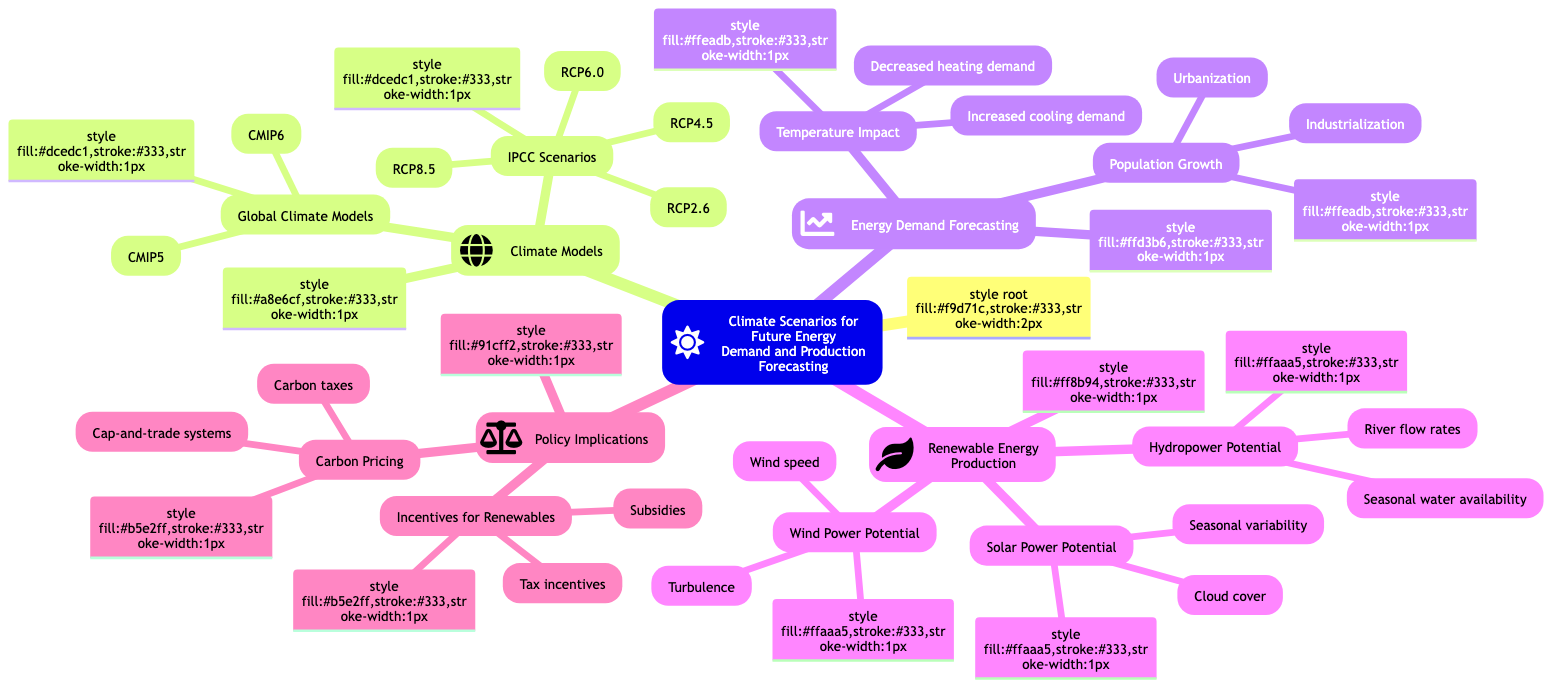What is the central theme of the diagram? The diagram is centered around the topic of climate scenarios and their implications for future energy demand and production forecasting.
Answer: Climate Scenarios for Future Energy Demand and Production Forecasting How many IPCC scenarios are listed? There are four IPCC scenarios depicted in the diagram: RCP2.6, RCP4.5, RCP6.0, and RCP8.5.
Answer: Four What does "Temperature Impact" relate to in energy demand forecasting? "Temperature Impact" addresses how changes in temperature influence energy needs, specifically mentioning increased cooling demand and decreased heating demand.
Answer: Increased cooling demand and decreased heating demand What are two factors affecting Solar Power Potential? The two factors affecting Solar Power Potential are cloud cover and seasonal variability.
Answer: Cloud cover and seasonal variability What is one example of a carbon pricing mechanism? The diagram lists carbon taxes and cap-and-trade systems as examples of carbon pricing mechanisms.
Answer: Carbon taxes or cap-and-trade systems Which climate model versions are mentioned? The diagram refers to two climate model versions: CMIP5 and CMIP6.
Answer: CMIP5 and CMIP6 What are the implications of population growth on energy consumption? Population growth influences energy consumption, particularly through urbanization and industrialization.
Answer: Urbanization and industrialization What are two impacts on Hydropower Potential? The two impacts on Hydropower Potential include changes in river flow rates and seasonal water availability.
Answer: River flow rates and seasonal water availability What type of incentives are mentioned for renewable energy? The diagram mentions subsidies and tax incentives as government incentives for renewable energy adoption.
Answer: Subsidies and tax incentives 